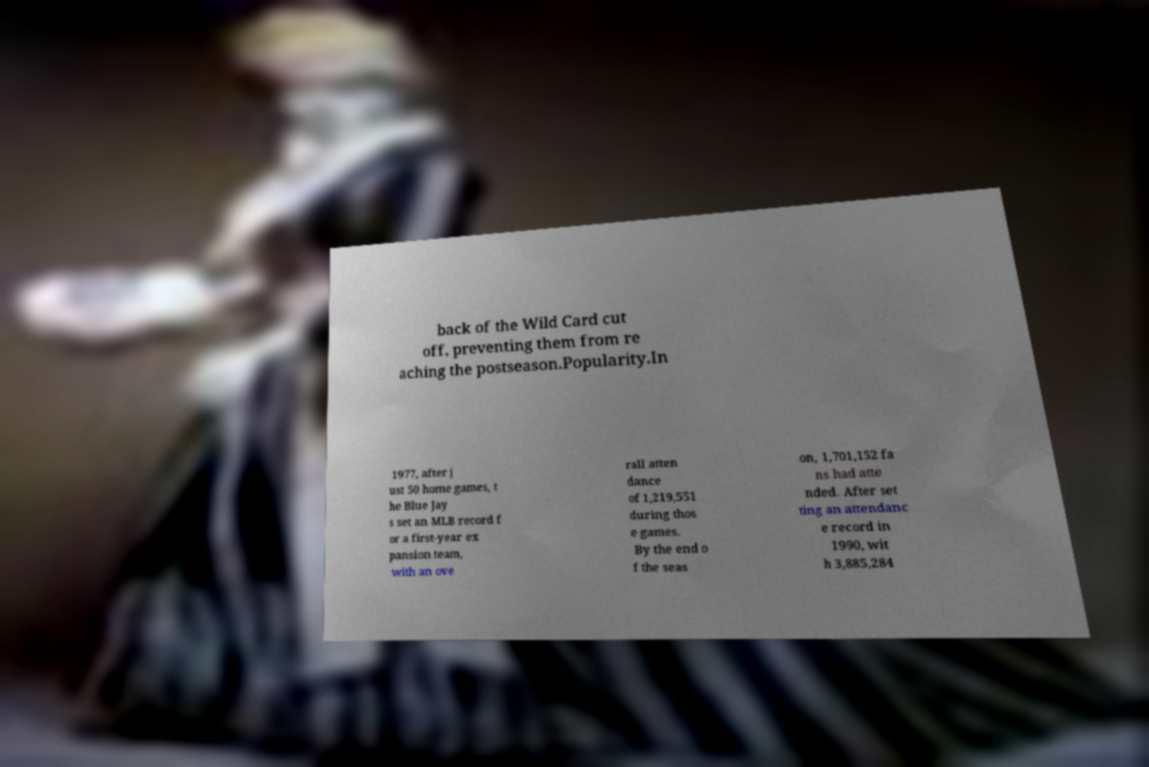For documentation purposes, I need the text within this image transcribed. Could you provide that? back of the Wild Card cut off, preventing them from re aching the postseason.Popularity.In 1977, after j ust 50 home games, t he Blue Jay s set an MLB record f or a first-year ex pansion team, with an ove rall atten dance of 1,219,551 during thos e games. By the end o f the seas on, 1,701,152 fa ns had atte nded. After set ting an attendanc e record in 1990, wit h 3,885,284 